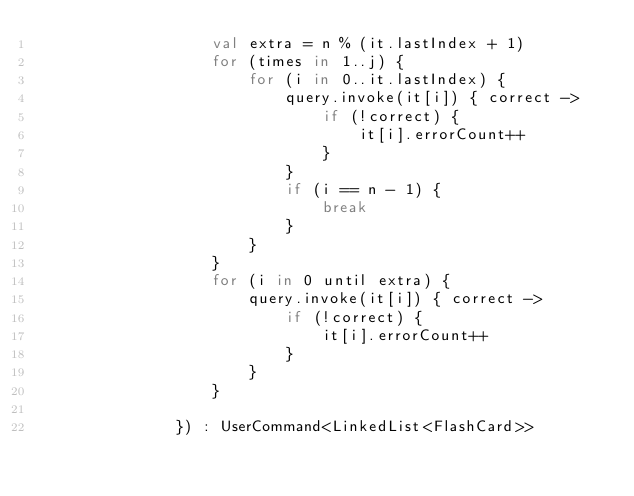Convert code to text. <code><loc_0><loc_0><loc_500><loc_500><_Kotlin_>                   val extra = n % (it.lastIndex + 1)
                   for (times in 1..j) {
                       for (i in 0..it.lastIndex) {
                           query.invoke(it[i]) { correct ->
                               if (!correct) {
                                   it[i].errorCount++
                               }
                           }
                           if (i == n - 1) {
                               break
                           }
                       }
                   }
                   for (i in 0 until extra) {
                       query.invoke(it[i]) { correct ->
                           if (!correct) {
                               it[i].errorCount++
                           }
                       }
                   }

               }) : UserCommand<LinkedList<FlashCard>>


</code> 